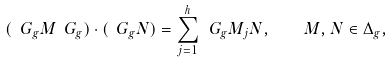<formula> <loc_0><loc_0><loc_500><loc_500>( \ G _ { g } M \ G _ { g } ) \cdot ( \ G _ { g } N ) = \sum _ { j = 1 } ^ { h } \ G _ { g } M _ { j } N , \quad M , N \in \Delta _ { g } ,</formula> 